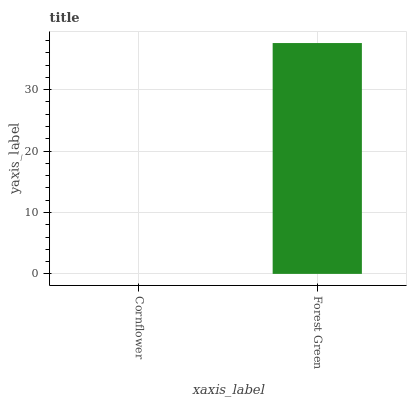Is Cornflower the minimum?
Answer yes or no. Yes. Is Forest Green the maximum?
Answer yes or no. Yes. Is Forest Green the minimum?
Answer yes or no. No. Is Forest Green greater than Cornflower?
Answer yes or no. Yes. Is Cornflower less than Forest Green?
Answer yes or no. Yes. Is Cornflower greater than Forest Green?
Answer yes or no. No. Is Forest Green less than Cornflower?
Answer yes or no. No. Is Forest Green the high median?
Answer yes or no. Yes. Is Cornflower the low median?
Answer yes or no. Yes. Is Cornflower the high median?
Answer yes or no. No. Is Forest Green the low median?
Answer yes or no. No. 